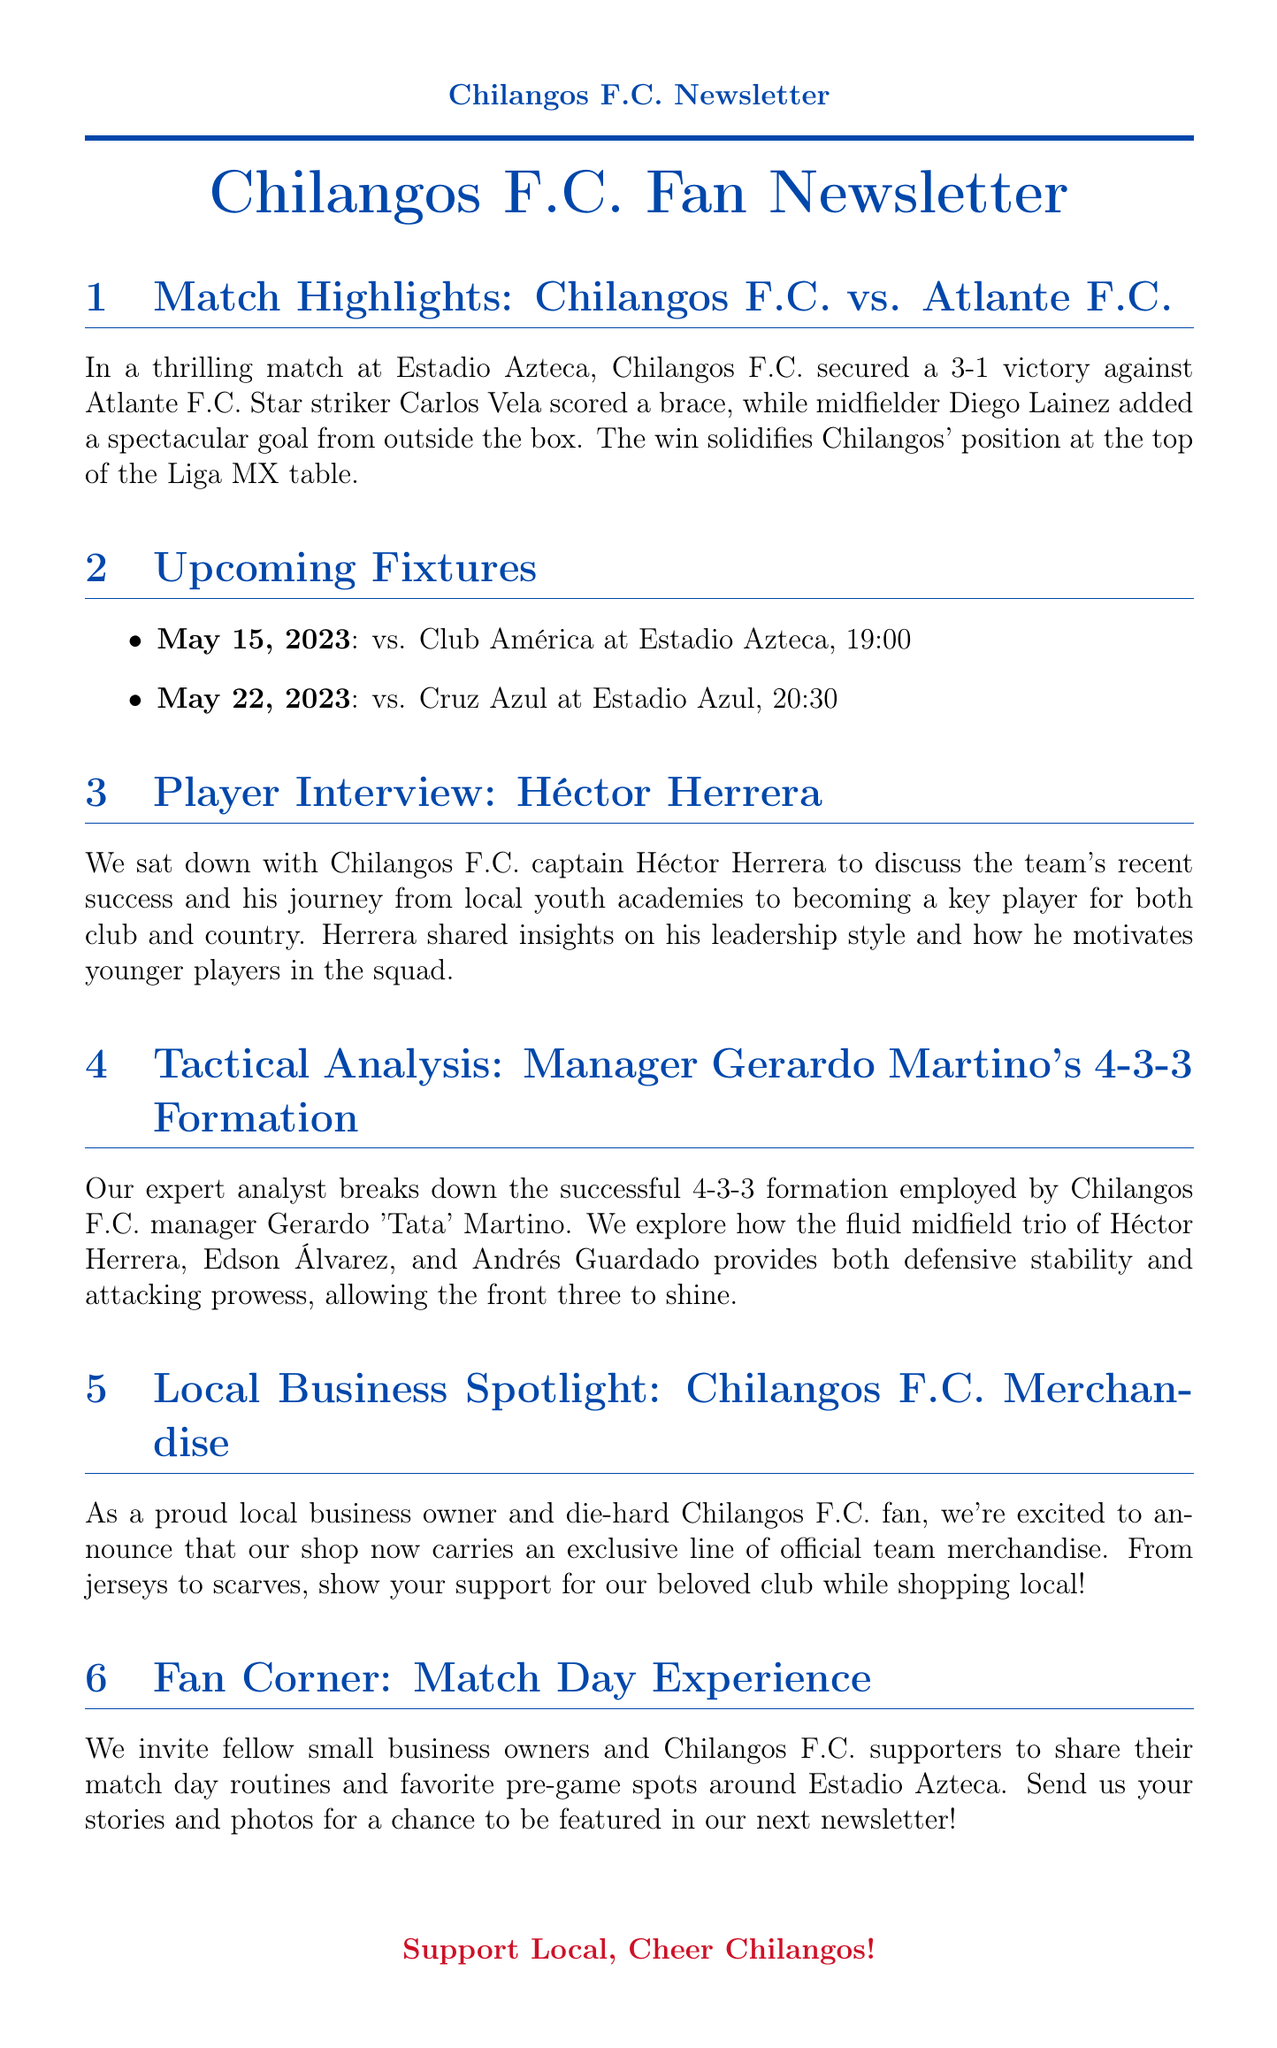What was the final score of the match against Atlante F.C.? The score mentioned in the highlights of the match is 3-1 in favor of Chilangos F.C.
Answer: 3-1 Who scored two goals in the match? The document states that star striker Carlos Vela scored a brace, meaning two goals.
Answer: Carlos Vela When is the upcoming match against Club América? The document provides the date of the match against Club América as May 15, 2023.
Answer: May 15, 2023 Who did manager Gerardo Martino implement in the midfield trio? The analysis mentions Héctor Herrera, Edson Álvarez, and Andrés Guardado as part of the successful midfield trio.
Answer: Héctor Herrera, Edson Álvarez, and Andrés Guardado What venue will Chilangos F.C. play at on May 22, 2023? The upcoming fixtures list the venue for the match against Cruz Azul as Estadio Azul.
Answer: Estadio Azul What is the main theme of the Local Business Spotlight section? The section promotes an exclusive line of official team merchandise available at a local shop.
Answer: Official team merchandise What kind of insights did Héctor Herrera share in his interview? The interview discusses his leadership style and how he motivates younger players.
Answer: Leadership style and motivation What invitation is extended to fellow small business owners in the Fan Corner section? The Fan Corner invites supporters to share their match day routines and favorite pre-game spots.
Answer: Share their match day routines and favorite pre-game spots 